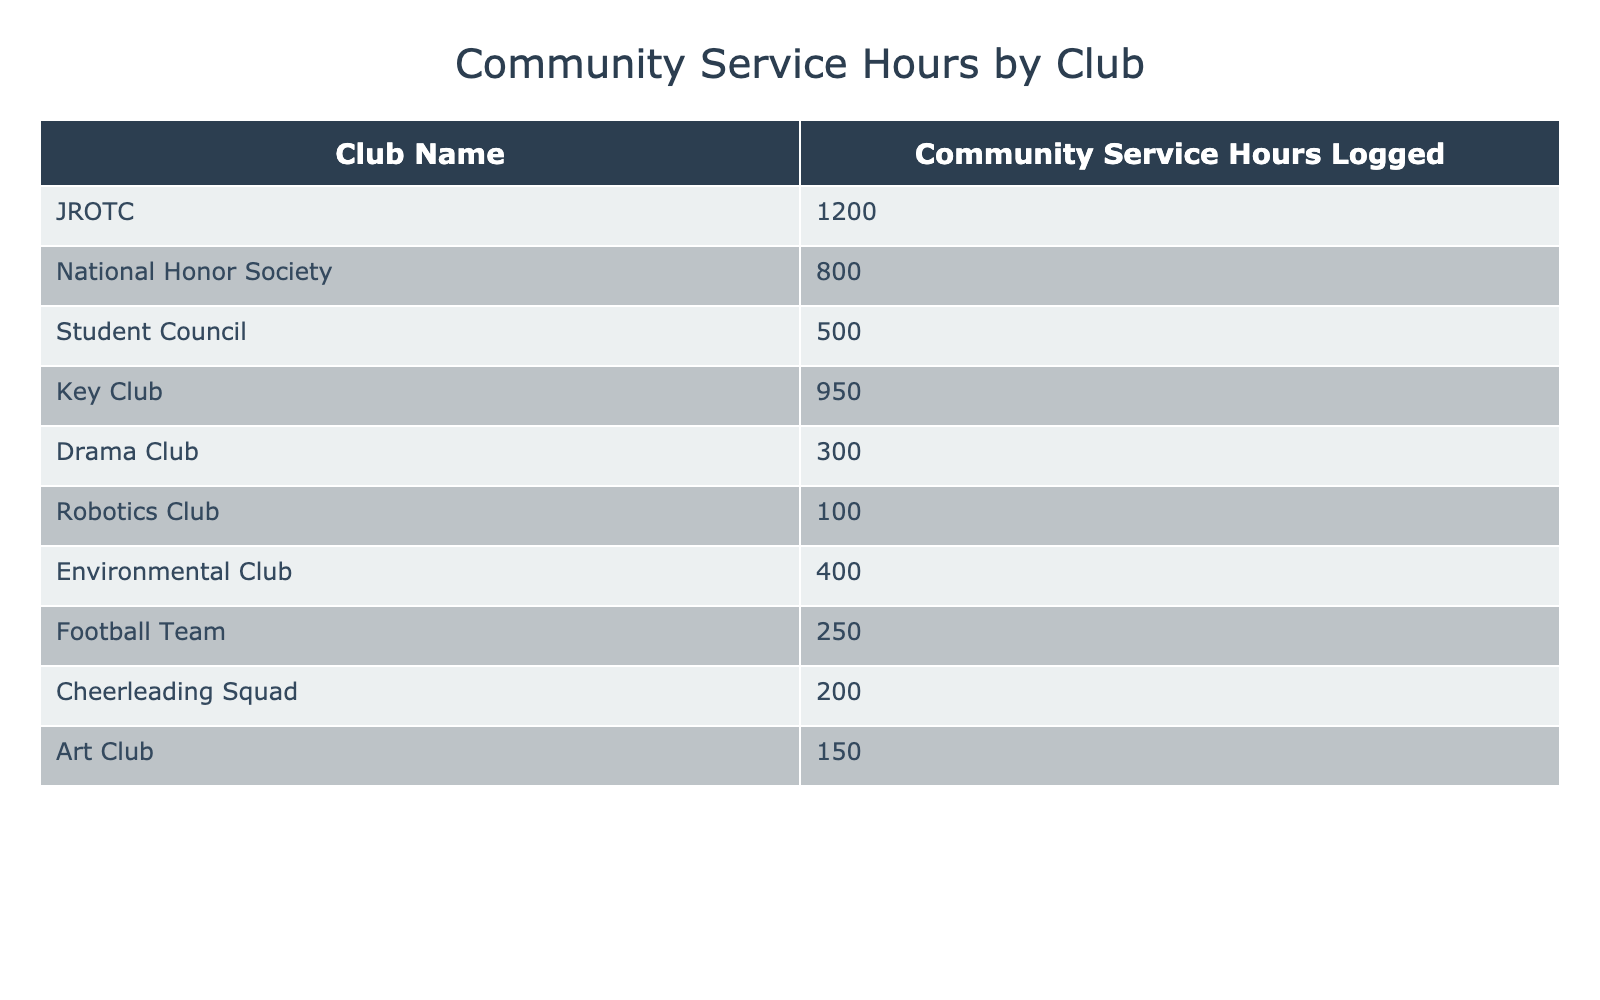Which club logged the most community service hours? Looking at the table, JROTC shows the highest community service hours logged at 1200.
Answer: JROTC How many hours did the National Honor Society log? The table specifies that the National Honor Society logged 800 community service hours.
Answer: 800 What is the total amount of community service hours logged by all clubs combined? To find the total, we add the hours of each club: 1200 + 800 + 500 + 950 + 300 + 100 + 400 + 250 + 200 + 150 = 3850 hours.
Answer: 3850 Is the community service logged by the Key Club greater than that of the Student Council? The Key Club logged 950 hours and the Student Council logged 500 hours. Since 950 is greater than 500, the statement is true.
Answer: Yes What is the average number of community service hours logged by all the clubs? To find the average, we sum the hours (3850 from the previous question) and divide by the number of clubs (10): 3850 / 10 = 385.
Answer: 385 Which clubs logged fewer than 400 service hours? The clubs logged fewer than 400 hours are Drama Club (300), Robotics Club (100), Football Team (250), Cheerleading Squad (200), and Art Club (150), totaling 5 clubs.
Answer: 5 clubs How many more hours did JROTC log compared to the second highest club? The second highest is the National Honor Society with 800 hours. The difference is 1200 - 800 = 400.
Answer: 400 Did any other club log more than 1000 hours? Only JROTC logged more than 1000 hours, as it is the only club reaching 1200 hours.
Answer: No What is the combined total of community service hours for clubs with more than 600 hours logged? The clubs logging more than 600 hours are JROTC (1200), National Honor Society (800), Key Club (950). The combined total is 1200 + 800 + 950 = 2950 hours.
Answer: 2950 